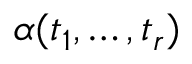Convert formula to latex. <formula><loc_0><loc_0><loc_500><loc_500>\alpha ( t _ { 1 } , \dots , t _ { r } )</formula> 